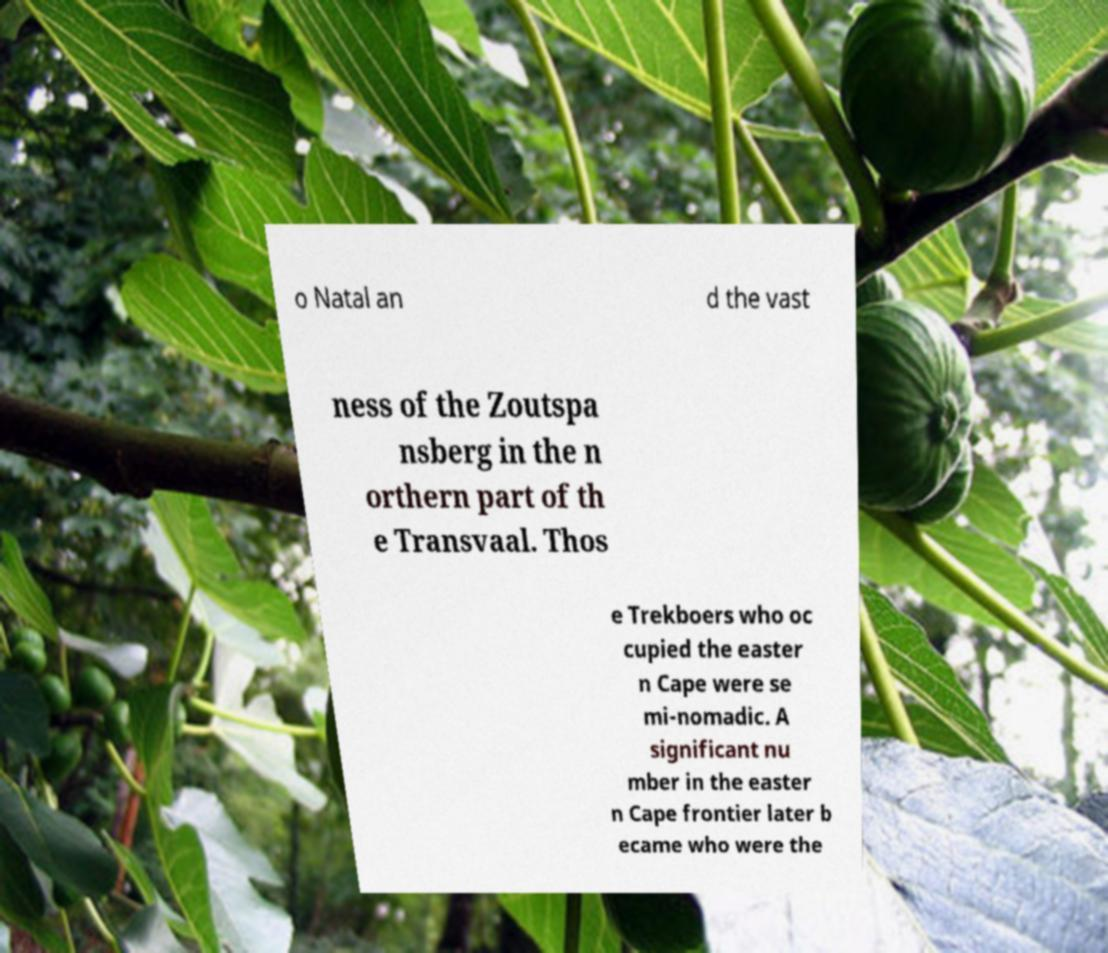There's text embedded in this image that I need extracted. Can you transcribe it verbatim? o Natal an d the vast ness of the Zoutspa nsberg in the n orthern part of th e Transvaal. Thos e Trekboers who oc cupied the easter n Cape were se mi-nomadic. A significant nu mber in the easter n Cape frontier later b ecame who were the 